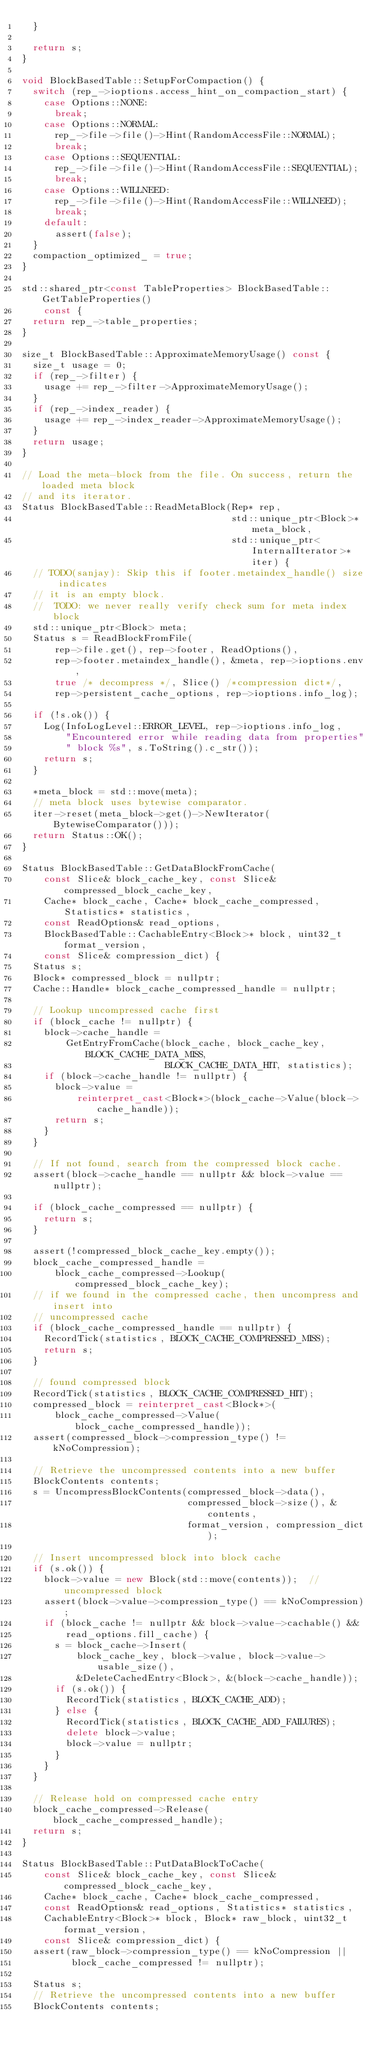<code> <loc_0><loc_0><loc_500><loc_500><_C++_>  }

  return s;
}

void BlockBasedTable::SetupForCompaction() {
  switch (rep_->ioptions.access_hint_on_compaction_start) {
    case Options::NONE:
      break;
    case Options::NORMAL:
      rep_->file->file()->Hint(RandomAccessFile::NORMAL);
      break;
    case Options::SEQUENTIAL:
      rep_->file->file()->Hint(RandomAccessFile::SEQUENTIAL);
      break;
    case Options::WILLNEED:
      rep_->file->file()->Hint(RandomAccessFile::WILLNEED);
      break;
    default:
      assert(false);
  }
  compaction_optimized_ = true;
}

std::shared_ptr<const TableProperties> BlockBasedTable::GetTableProperties()
    const {
  return rep_->table_properties;
}

size_t BlockBasedTable::ApproximateMemoryUsage() const {
  size_t usage = 0;
  if (rep_->filter) {
    usage += rep_->filter->ApproximateMemoryUsage();
  }
  if (rep_->index_reader) {
    usage += rep_->index_reader->ApproximateMemoryUsage();
  }
  return usage;
}

// Load the meta-block from the file. On success, return the loaded meta block
// and its iterator.
Status BlockBasedTable::ReadMetaBlock(Rep* rep,
                                      std::unique_ptr<Block>* meta_block,
                                      std::unique_ptr<InternalIterator>* iter) {
  // TODO(sanjay): Skip this if footer.metaindex_handle() size indicates
  // it is an empty block.
  //  TODO: we never really verify check sum for meta index block
  std::unique_ptr<Block> meta;
  Status s = ReadBlockFromFile(
      rep->file.get(), rep->footer, ReadOptions(),
      rep->footer.metaindex_handle(), &meta, rep->ioptions.env,
      true /* decompress */, Slice() /*compression dict*/,
      rep->persistent_cache_options, rep->ioptions.info_log);

  if (!s.ok()) {
    Log(InfoLogLevel::ERROR_LEVEL, rep->ioptions.info_log,
        "Encountered error while reading data from properties"
        " block %s", s.ToString().c_str());
    return s;
  }

  *meta_block = std::move(meta);
  // meta block uses bytewise comparator.
  iter->reset(meta_block->get()->NewIterator(BytewiseComparator()));
  return Status::OK();
}

Status BlockBasedTable::GetDataBlockFromCache(
    const Slice& block_cache_key, const Slice& compressed_block_cache_key,
    Cache* block_cache, Cache* block_cache_compressed, Statistics* statistics,
    const ReadOptions& read_options,
    BlockBasedTable::CachableEntry<Block>* block, uint32_t format_version,
    const Slice& compression_dict) {
  Status s;
  Block* compressed_block = nullptr;
  Cache::Handle* block_cache_compressed_handle = nullptr;

  // Lookup uncompressed cache first
  if (block_cache != nullptr) {
    block->cache_handle =
        GetEntryFromCache(block_cache, block_cache_key, BLOCK_CACHE_DATA_MISS,
                          BLOCK_CACHE_DATA_HIT, statistics);
    if (block->cache_handle != nullptr) {
      block->value =
          reinterpret_cast<Block*>(block_cache->Value(block->cache_handle));
      return s;
    }
  }

  // If not found, search from the compressed block cache.
  assert(block->cache_handle == nullptr && block->value == nullptr);

  if (block_cache_compressed == nullptr) {
    return s;
  }

  assert(!compressed_block_cache_key.empty());
  block_cache_compressed_handle =
      block_cache_compressed->Lookup(compressed_block_cache_key);
  // if we found in the compressed cache, then uncompress and insert into
  // uncompressed cache
  if (block_cache_compressed_handle == nullptr) {
    RecordTick(statistics, BLOCK_CACHE_COMPRESSED_MISS);
    return s;
  }

  // found compressed block
  RecordTick(statistics, BLOCK_CACHE_COMPRESSED_HIT);
  compressed_block = reinterpret_cast<Block*>(
      block_cache_compressed->Value(block_cache_compressed_handle));
  assert(compressed_block->compression_type() != kNoCompression);

  // Retrieve the uncompressed contents into a new buffer
  BlockContents contents;
  s = UncompressBlockContents(compressed_block->data(),
                              compressed_block->size(), &contents,
                              format_version, compression_dict);

  // Insert uncompressed block into block cache
  if (s.ok()) {
    block->value = new Block(std::move(contents));  // uncompressed block
    assert(block->value->compression_type() == kNoCompression);
    if (block_cache != nullptr && block->value->cachable() &&
        read_options.fill_cache) {
      s = block_cache->Insert(
          block_cache_key, block->value, block->value->usable_size(),
          &DeleteCachedEntry<Block>, &(block->cache_handle));
      if (s.ok()) {
        RecordTick(statistics, BLOCK_CACHE_ADD);
      } else {
        RecordTick(statistics, BLOCK_CACHE_ADD_FAILURES);
        delete block->value;
        block->value = nullptr;
      }
    }
  }

  // Release hold on compressed cache entry
  block_cache_compressed->Release(block_cache_compressed_handle);
  return s;
}

Status BlockBasedTable::PutDataBlockToCache(
    const Slice& block_cache_key, const Slice& compressed_block_cache_key,
    Cache* block_cache, Cache* block_cache_compressed,
    const ReadOptions& read_options, Statistics* statistics,
    CachableEntry<Block>* block, Block* raw_block, uint32_t format_version,
    const Slice& compression_dict) {
  assert(raw_block->compression_type() == kNoCompression ||
         block_cache_compressed != nullptr);

  Status s;
  // Retrieve the uncompressed contents into a new buffer
  BlockContents contents;</code> 